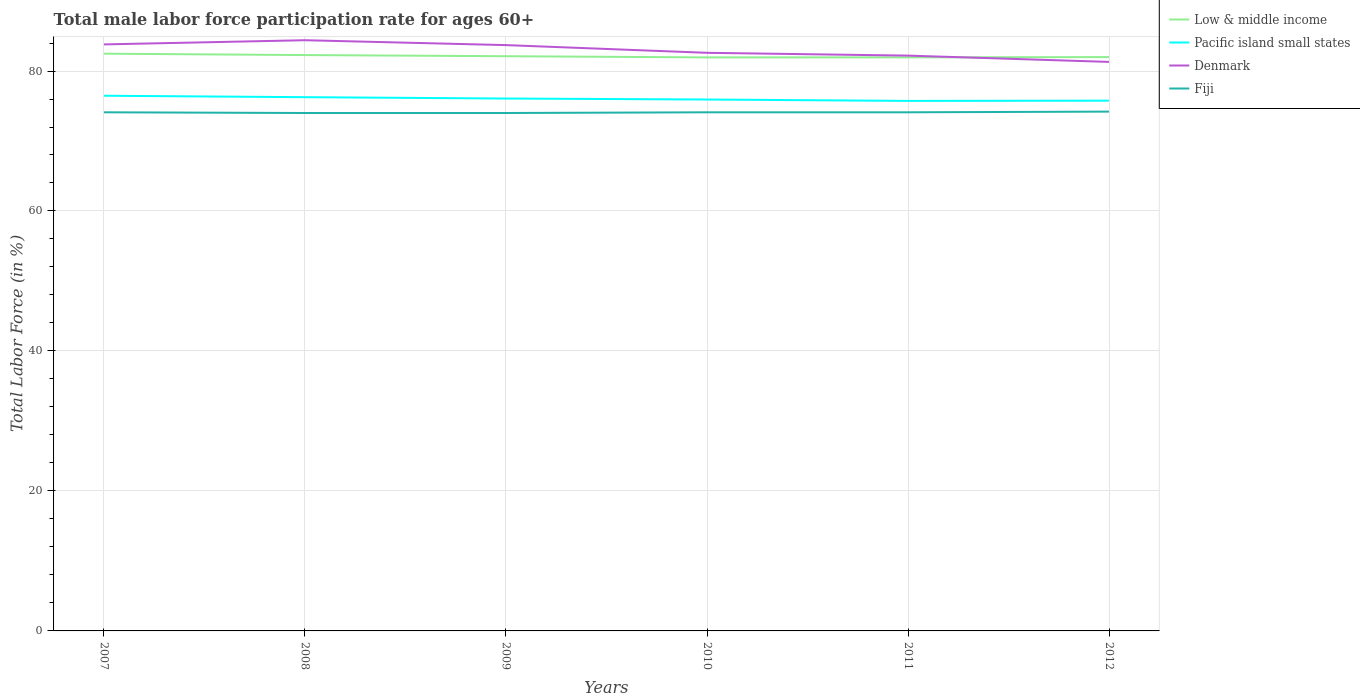Across all years, what is the maximum male labor force participation rate in Pacific island small states?
Ensure brevity in your answer.  75.73. In which year was the male labor force participation rate in Denmark maximum?
Your answer should be very brief. 2012. What is the total male labor force participation rate in Pacific island small states in the graph?
Make the answer very short. 0.14. What is the difference between the highest and the second highest male labor force participation rate in Fiji?
Your answer should be compact. 0.2. How many lines are there?
Your response must be concise. 4. How many years are there in the graph?
Make the answer very short. 6. What is the difference between two consecutive major ticks on the Y-axis?
Your answer should be very brief. 20. Does the graph contain any zero values?
Your answer should be very brief. No. Where does the legend appear in the graph?
Make the answer very short. Top right. How many legend labels are there?
Keep it short and to the point. 4. What is the title of the graph?
Offer a very short reply. Total male labor force participation rate for ages 60+. What is the label or title of the X-axis?
Your response must be concise. Years. What is the Total Labor Force (in %) in Low & middle income in 2007?
Keep it short and to the point. 82.47. What is the Total Labor Force (in %) in Pacific island small states in 2007?
Your answer should be very brief. 76.47. What is the Total Labor Force (in %) of Denmark in 2007?
Give a very brief answer. 83.8. What is the Total Labor Force (in %) of Fiji in 2007?
Ensure brevity in your answer.  74.1. What is the Total Labor Force (in %) in Low & middle income in 2008?
Provide a succinct answer. 82.28. What is the Total Labor Force (in %) of Pacific island small states in 2008?
Your answer should be very brief. 76.26. What is the Total Labor Force (in %) of Denmark in 2008?
Ensure brevity in your answer.  84.4. What is the Total Labor Force (in %) in Low & middle income in 2009?
Keep it short and to the point. 82.11. What is the Total Labor Force (in %) in Pacific island small states in 2009?
Ensure brevity in your answer.  76.07. What is the Total Labor Force (in %) of Denmark in 2009?
Your answer should be compact. 83.7. What is the Total Labor Force (in %) in Low & middle income in 2010?
Provide a short and direct response. 81.94. What is the Total Labor Force (in %) in Pacific island small states in 2010?
Make the answer very short. 75.93. What is the Total Labor Force (in %) in Denmark in 2010?
Ensure brevity in your answer.  82.6. What is the Total Labor Force (in %) of Fiji in 2010?
Make the answer very short. 74.1. What is the Total Labor Force (in %) of Low & middle income in 2011?
Make the answer very short. 81.95. What is the Total Labor Force (in %) of Pacific island small states in 2011?
Ensure brevity in your answer.  75.73. What is the Total Labor Force (in %) in Denmark in 2011?
Offer a terse response. 82.2. What is the Total Labor Force (in %) of Fiji in 2011?
Make the answer very short. 74.1. What is the Total Labor Force (in %) in Low & middle income in 2012?
Your response must be concise. 81.99. What is the Total Labor Force (in %) in Pacific island small states in 2012?
Your answer should be very brief. 75.76. What is the Total Labor Force (in %) of Denmark in 2012?
Your response must be concise. 81.3. What is the Total Labor Force (in %) in Fiji in 2012?
Your response must be concise. 74.2. Across all years, what is the maximum Total Labor Force (in %) of Low & middle income?
Your answer should be very brief. 82.47. Across all years, what is the maximum Total Labor Force (in %) in Pacific island small states?
Provide a succinct answer. 76.47. Across all years, what is the maximum Total Labor Force (in %) in Denmark?
Keep it short and to the point. 84.4. Across all years, what is the maximum Total Labor Force (in %) in Fiji?
Keep it short and to the point. 74.2. Across all years, what is the minimum Total Labor Force (in %) in Low & middle income?
Your response must be concise. 81.94. Across all years, what is the minimum Total Labor Force (in %) in Pacific island small states?
Your answer should be compact. 75.73. Across all years, what is the minimum Total Labor Force (in %) in Denmark?
Keep it short and to the point. 81.3. What is the total Total Labor Force (in %) of Low & middle income in the graph?
Offer a very short reply. 492.75. What is the total Total Labor Force (in %) in Pacific island small states in the graph?
Make the answer very short. 456.22. What is the total Total Labor Force (in %) of Denmark in the graph?
Make the answer very short. 498. What is the total Total Labor Force (in %) of Fiji in the graph?
Your answer should be very brief. 444.5. What is the difference between the Total Labor Force (in %) in Low & middle income in 2007 and that in 2008?
Offer a terse response. 0.2. What is the difference between the Total Labor Force (in %) of Pacific island small states in 2007 and that in 2008?
Keep it short and to the point. 0.21. What is the difference between the Total Labor Force (in %) of Denmark in 2007 and that in 2008?
Provide a succinct answer. -0.6. What is the difference between the Total Labor Force (in %) of Fiji in 2007 and that in 2008?
Your answer should be very brief. 0.1. What is the difference between the Total Labor Force (in %) in Low & middle income in 2007 and that in 2009?
Your response must be concise. 0.36. What is the difference between the Total Labor Force (in %) of Pacific island small states in 2007 and that in 2009?
Make the answer very short. 0.4. What is the difference between the Total Labor Force (in %) in Fiji in 2007 and that in 2009?
Make the answer very short. 0.1. What is the difference between the Total Labor Force (in %) of Low & middle income in 2007 and that in 2010?
Provide a short and direct response. 0.53. What is the difference between the Total Labor Force (in %) in Pacific island small states in 2007 and that in 2010?
Keep it short and to the point. 0.54. What is the difference between the Total Labor Force (in %) of Denmark in 2007 and that in 2010?
Your response must be concise. 1.2. What is the difference between the Total Labor Force (in %) of Low & middle income in 2007 and that in 2011?
Provide a succinct answer. 0.52. What is the difference between the Total Labor Force (in %) in Pacific island small states in 2007 and that in 2011?
Make the answer very short. 0.74. What is the difference between the Total Labor Force (in %) of Low & middle income in 2007 and that in 2012?
Provide a short and direct response. 0.48. What is the difference between the Total Labor Force (in %) in Pacific island small states in 2007 and that in 2012?
Offer a terse response. 0.7. What is the difference between the Total Labor Force (in %) of Denmark in 2007 and that in 2012?
Your answer should be very brief. 2.5. What is the difference between the Total Labor Force (in %) of Low & middle income in 2008 and that in 2009?
Offer a terse response. 0.17. What is the difference between the Total Labor Force (in %) in Pacific island small states in 2008 and that in 2009?
Make the answer very short. 0.19. What is the difference between the Total Labor Force (in %) in Low & middle income in 2008 and that in 2010?
Your answer should be very brief. 0.33. What is the difference between the Total Labor Force (in %) of Pacific island small states in 2008 and that in 2010?
Your answer should be very brief. 0.34. What is the difference between the Total Labor Force (in %) of Denmark in 2008 and that in 2010?
Keep it short and to the point. 1.8. What is the difference between the Total Labor Force (in %) in Fiji in 2008 and that in 2010?
Provide a succinct answer. -0.1. What is the difference between the Total Labor Force (in %) of Low & middle income in 2008 and that in 2011?
Offer a very short reply. 0.33. What is the difference between the Total Labor Force (in %) in Pacific island small states in 2008 and that in 2011?
Make the answer very short. 0.54. What is the difference between the Total Labor Force (in %) of Low & middle income in 2008 and that in 2012?
Provide a short and direct response. 0.29. What is the difference between the Total Labor Force (in %) of Pacific island small states in 2008 and that in 2012?
Ensure brevity in your answer.  0.5. What is the difference between the Total Labor Force (in %) in Denmark in 2008 and that in 2012?
Your response must be concise. 3.1. What is the difference between the Total Labor Force (in %) of Fiji in 2008 and that in 2012?
Keep it short and to the point. -0.2. What is the difference between the Total Labor Force (in %) of Low & middle income in 2009 and that in 2010?
Make the answer very short. 0.17. What is the difference between the Total Labor Force (in %) in Pacific island small states in 2009 and that in 2010?
Provide a short and direct response. 0.14. What is the difference between the Total Labor Force (in %) of Denmark in 2009 and that in 2010?
Ensure brevity in your answer.  1.1. What is the difference between the Total Labor Force (in %) of Fiji in 2009 and that in 2010?
Your answer should be compact. -0.1. What is the difference between the Total Labor Force (in %) in Low & middle income in 2009 and that in 2011?
Your answer should be very brief. 0.16. What is the difference between the Total Labor Force (in %) of Pacific island small states in 2009 and that in 2011?
Provide a succinct answer. 0.34. What is the difference between the Total Labor Force (in %) of Fiji in 2009 and that in 2011?
Give a very brief answer. -0.1. What is the difference between the Total Labor Force (in %) in Low & middle income in 2009 and that in 2012?
Provide a short and direct response. 0.12. What is the difference between the Total Labor Force (in %) of Pacific island small states in 2009 and that in 2012?
Offer a very short reply. 0.3. What is the difference between the Total Labor Force (in %) of Denmark in 2009 and that in 2012?
Your answer should be very brief. 2.4. What is the difference between the Total Labor Force (in %) of Low & middle income in 2010 and that in 2011?
Ensure brevity in your answer.  -0.01. What is the difference between the Total Labor Force (in %) in Pacific island small states in 2010 and that in 2011?
Your answer should be very brief. 0.2. What is the difference between the Total Labor Force (in %) in Fiji in 2010 and that in 2011?
Provide a short and direct response. 0. What is the difference between the Total Labor Force (in %) of Low & middle income in 2010 and that in 2012?
Provide a succinct answer. -0.05. What is the difference between the Total Labor Force (in %) of Pacific island small states in 2010 and that in 2012?
Give a very brief answer. 0.16. What is the difference between the Total Labor Force (in %) in Fiji in 2010 and that in 2012?
Your response must be concise. -0.1. What is the difference between the Total Labor Force (in %) of Low & middle income in 2011 and that in 2012?
Provide a succinct answer. -0.04. What is the difference between the Total Labor Force (in %) in Pacific island small states in 2011 and that in 2012?
Provide a short and direct response. -0.04. What is the difference between the Total Labor Force (in %) of Low & middle income in 2007 and the Total Labor Force (in %) of Pacific island small states in 2008?
Make the answer very short. 6.21. What is the difference between the Total Labor Force (in %) of Low & middle income in 2007 and the Total Labor Force (in %) of Denmark in 2008?
Give a very brief answer. -1.93. What is the difference between the Total Labor Force (in %) in Low & middle income in 2007 and the Total Labor Force (in %) in Fiji in 2008?
Provide a short and direct response. 8.47. What is the difference between the Total Labor Force (in %) of Pacific island small states in 2007 and the Total Labor Force (in %) of Denmark in 2008?
Your answer should be compact. -7.93. What is the difference between the Total Labor Force (in %) in Pacific island small states in 2007 and the Total Labor Force (in %) in Fiji in 2008?
Provide a short and direct response. 2.47. What is the difference between the Total Labor Force (in %) of Denmark in 2007 and the Total Labor Force (in %) of Fiji in 2008?
Give a very brief answer. 9.8. What is the difference between the Total Labor Force (in %) in Low & middle income in 2007 and the Total Labor Force (in %) in Pacific island small states in 2009?
Provide a succinct answer. 6.41. What is the difference between the Total Labor Force (in %) in Low & middle income in 2007 and the Total Labor Force (in %) in Denmark in 2009?
Give a very brief answer. -1.23. What is the difference between the Total Labor Force (in %) of Low & middle income in 2007 and the Total Labor Force (in %) of Fiji in 2009?
Make the answer very short. 8.47. What is the difference between the Total Labor Force (in %) of Pacific island small states in 2007 and the Total Labor Force (in %) of Denmark in 2009?
Keep it short and to the point. -7.23. What is the difference between the Total Labor Force (in %) in Pacific island small states in 2007 and the Total Labor Force (in %) in Fiji in 2009?
Offer a very short reply. 2.47. What is the difference between the Total Labor Force (in %) in Denmark in 2007 and the Total Labor Force (in %) in Fiji in 2009?
Give a very brief answer. 9.8. What is the difference between the Total Labor Force (in %) of Low & middle income in 2007 and the Total Labor Force (in %) of Pacific island small states in 2010?
Provide a succinct answer. 6.55. What is the difference between the Total Labor Force (in %) of Low & middle income in 2007 and the Total Labor Force (in %) of Denmark in 2010?
Keep it short and to the point. -0.13. What is the difference between the Total Labor Force (in %) in Low & middle income in 2007 and the Total Labor Force (in %) in Fiji in 2010?
Offer a very short reply. 8.37. What is the difference between the Total Labor Force (in %) in Pacific island small states in 2007 and the Total Labor Force (in %) in Denmark in 2010?
Offer a terse response. -6.13. What is the difference between the Total Labor Force (in %) in Pacific island small states in 2007 and the Total Labor Force (in %) in Fiji in 2010?
Your response must be concise. 2.37. What is the difference between the Total Labor Force (in %) in Denmark in 2007 and the Total Labor Force (in %) in Fiji in 2010?
Give a very brief answer. 9.7. What is the difference between the Total Labor Force (in %) in Low & middle income in 2007 and the Total Labor Force (in %) in Pacific island small states in 2011?
Offer a very short reply. 6.75. What is the difference between the Total Labor Force (in %) of Low & middle income in 2007 and the Total Labor Force (in %) of Denmark in 2011?
Offer a very short reply. 0.27. What is the difference between the Total Labor Force (in %) of Low & middle income in 2007 and the Total Labor Force (in %) of Fiji in 2011?
Offer a terse response. 8.37. What is the difference between the Total Labor Force (in %) of Pacific island small states in 2007 and the Total Labor Force (in %) of Denmark in 2011?
Your answer should be compact. -5.73. What is the difference between the Total Labor Force (in %) in Pacific island small states in 2007 and the Total Labor Force (in %) in Fiji in 2011?
Give a very brief answer. 2.37. What is the difference between the Total Labor Force (in %) of Denmark in 2007 and the Total Labor Force (in %) of Fiji in 2011?
Provide a succinct answer. 9.7. What is the difference between the Total Labor Force (in %) of Low & middle income in 2007 and the Total Labor Force (in %) of Pacific island small states in 2012?
Ensure brevity in your answer.  6.71. What is the difference between the Total Labor Force (in %) in Low & middle income in 2007 and the Total Labor Force (in %) in Denmark in 2012?
Your answer should be compact. 1.17. What is the difference between the Total Labor Force (in %) in Low & middle income in 2007 and the Total Labor Force (in %) in Fiji in 2012?
Ensure brevity in your answer.  8.27. What is the difference between the Total Labor Force (in %) in Pacific island small states in 2007 and the Total Labor Force (in %) in Denmark in 2012?
Offer a terse response. -4.83. What is the difference between the Total Labor Force (in %) of Pacific island small states in 2007 and the Total Labor Force (in %) of Fiji in 2012?
Offer a very short reply. 2.27. What is the difference between the Total Labor Force (in %) of Low & middle income in 2008 and the Total Labor Force (in %) of Pacific island small states in 2009?
Your answer should be very brief. 6.21. What is the difference between the Total Labor Force (in %) in Low & middle income in 2008 and the Total Labor Force (in %) in Denmark in 2009?
Offer a terse response. -1.42. What is the difference between the Total Labor Force (in %) of Low & middle income in 2008 and the Total Labor Force (in %) of Fiji in 2009?
Offer a terse response. 8.28. What is the difference between the Total Labor Force (in %) of Pacific island small states in 2008 and the Total Labor Force (in %) of Denmark in 2009?
Provide a short and direct response. -7.44. What is the difference between the Total Labor Force (in %) in Pacific island small states in 2008 and the Total Labor Force (in %) in Fiji in 2009?
Your answer should be very brief. 2.26. What is the difference between the Total Labor Force (in %) in Denmark in 2008 and the Total Labor Force (in %) in Fiji in 2009?
Make the answer very short. 10.4. What is the difference between the Total Labor Force (in %) in Low & middle income in 2008 and the Total Labor Force (in %) in Pacific island small states in 2010?
Give a very brief answer. 6.35. What is the difference between the Total Labor Force (in %) in Low & middle income in 2008 and the Total Labor Force (in %) in Denmark in 2010?
Your response must be concise. -0.32. What is the difference between the Total Labor Force (in %) of Low & middle income in 2008 and the Total Labor Force (in %) of Fiji in 2010?
Offer a terse response. 8.18. What is the difference between the Total Labor Force (in %) in Pacific island small states in 2008 and the Total Labor Force (in %) in Denmark in 2010?
Provide a short and direct response. -6.34. What is the difference between the Total Labor Force (in %) in Pacific island small states in 2008 and the Total Labor Force (in %) in Fiji in 2010?
Make the answer very short. 2.16. What is the difference between the Total Labor Force (in %) of Low & middle income in 2008 and the Total Labor Force (in %) of Pacific island small states in 2011?
Offer a terse response. 6.55. What is the difference between the Total Labor Force (in %) of Low & middle income in 2008 and the Total Labor Force (in %) of Denmark in 2011?
Provide a short and direct response. 0.08. What is the difference between the Total Labor Force (in %) of Low & middle income in 2008 and the Total Labor Force (in %) of Fiji in 2011?
Offer a terse response. 8.18. What is the difference between the Total Labor Force (in %) in Pacific island small states in 2008 and the Total Labor Force (in %) in Denmark in 2011?
Offer a very short reply. -5.94. What is the difference between the Total Labor Force (in %) of Pacific island small states in 2008 and the Total Labor Force (in %) of Fiji in 2011?
Give a very brief answer. 2.16. What is the difference between the Total Labor Force (in %) in Low & middle income in 2008 and the Total Labor Force (in %) in Pacific island small states in 2012?
Give a very brief answer. 6.52. What is the difference between the Total Labor Force (in %) of Low & middle income in 2008 and the Total Labor Force (in %) of Denmark in 2012?
Give a very brief answer. 0.98. What is the difference between the Total Labor Force (in %) of Low & middle income in 2008 and the Total Labor Force (in %) of Fiji in 2012?
Your response must be concise. 8.08. What is the difference between the Total Labor Force (in %) of Pacific island small states in 2008 and the Total Labor Force (in %) of Denmark in 2012?
Offer a very short reply. -5.04. What is the difference between the Total Labor Force (in %) in Pacific island small states in 2008 and the Total Labor Force (in %) in Fiji in 2012?
Your answer should be compact. 2.06. What is the difference between the Total Labor Force (in %) in Denmark in 2008 and the Total Labor Force (in %) in Fiji in 2012?
Your answer should be compact. 10.2. What is the difference between the Total Labor Force (in %) in Low & middle income in 2009 and the Total Labor Force (in %) in Pacific island small states in 2010?
Your answer should be compact. 6.19. What is the difference between the Total Labor Force (in %) of Low & middle income in 2009 and the Total Labor Force (in %) of Denmark in 2010?
Keep it short and to the point. -0.49. What is the difference between the Total Labor Force (in %) of Low & middle income in 2009 and the Total Labor Force (in %) of Fiji in 2010?
Keep it short and to the point. 8.01. What is the difference between the Total Labor Force (in %) of Pacific island small states in 2009 and the Total Labor Force (in %) of Denmark in 2010?
Provide a succinct answer. -6.53. What is the difference between the Total Labor Force (in %) in Pacific island small states in 2009 and the Total Labor Force (in %) in Fiji in 2010?
Make the answer very short. 1.97. What is the difference between the Total Labor Force (in %) in Denmark in 2009 and the Total Labor Force (in %) in Fiji in 2010?
Offer a very short reply. 9.6. What is the difference between the Total Labor Force (in %) of Low & middle income in 2009 and the Total Labor Force (in %) of Pacific island small states in 2011?
Keep it short and to the point. 6.39. What is the difference between the Total Labor Force (in %) in Low & middle income in 2009 and the Total Labor Force (in %) in Denmark in 2011?
Provide a short and direct response. -0.09. What is the difference between the Total Labor Force (in %) of Low & middle income in 2009 and the Total Labor Force (in %) of Fiji in 2011?
Offer a very short reply. 8.01. What is the difference between the Total Labor Force (in %) of Pacific island small states in 2009 and the Total Labor Force (in %) of Denmark in 2011?
Your answer should be very brief. -6.13. What is the difference between the Total Labor Force (in %) in Pacific island small states in 2009 and the Total Labor Force (in %) in Fiji in 2011?
Provide a short and direct response. 1.97. What is the difference between the Total Labor Force (in %) in Low & middle income in 2009 and the Total Labor Force (in %) in Pacific island small states in 2012?
Offer a terse response. 6.35. What is the difference between the Total Labor Force (in %) in Low & middle income in 2009 and the Total Labor Force (in %) in Denmark in 2012?
Your answer should be very brief. 0.81. What is the difference between the Total Labor Force (in %) of Low & middle income in 2009 and the Total Labor Force (in %) of Fiji in 2012?
Your response must be concise. 7.91. What is the difference between the Total Labor Force (in %) in Pacific island small states in 2009 and the Total Labor Force (in %) in Denmark in 2012?
Provide a short and direct response. -5.23. What is the difference between the Total Labor Force (in %) in Pacific island small states in 2009 and the Total Labor Force (in %) in Fiji in 2012?
Give a very brief answer. 1.87. What is the difference between the Total Labor Force (in %) in Denmark in 2009 and the Total Labor Force (in %) in Fiji in 2012?
Give a very brief answer. 9.5. What is the difference between the Total Labor Force (in %) of Low & middle income in 2010 and the Total Labor Force (in %) of Pacific island small states in 2011?
Keep it short and to the point. 6.22. What is the difference between the Total Labor Force (in %) of Low & middle income in 2010 and the Total Labor Force (in %) of Denmark in 2011?
Provide a short and direct response. -0.26. What is the difference between the Total Labor Force (in %) in Low & middle income in 2010 and the Total Labor Force (in %) in Fiji in 2011?
Ensure brevity in your answer.  7.84. What is the difference between the Total Labor Force (in %) in Pacific island small states in 2010 and the Total Labor Force (in %) in Denmark in 2011?
Keep it short and to the point. -6.27. What is the difference between the Total Labor Force (in %) in Pacific island small states in 2010 and the Total Labor Force (in %) in Fiji in 2011?
Ensure brevity in your answer.  1.83. What is the difference between the Total Labor Force (in %) of Low & middle income in 2010 and the Total Labor Force (in %) of Pacific island small states in 2012?
Make the answer very short. 6.18. What is the difference between the Total Labor Force (in %) of Low & middle income in 2010 and the Total Labor Force (in %) of Denmark in 2012?
Provide a succinct answer. 0.64. What is the difference between the Total Labor Force (in %) of Low & middle income in 2010 and the Total Labor Force (in %) of Fiji in 2012?
Your response must be concise. 7.74. What is the difference between the Total Labor Force (in %) of Pacific island small states in 2010 and the Total Labor Force (in %) of Denmark in 2012?
Provide a succinct answer. -5.37. What is the difference between the Total Labor Force (in %) in Pacific island small states in 2010 and the Total Labor Force (in %) in Fiji in 2012?
Make the answer very short. 1.73. What is the difference between the Total Labor Force (in %) in Denmark in 2010 and the Total Labor Force (in %) in Fiji in 2012?
Your answer should be compact. 8.4. What is the difference between the Total Labor Force (in %) in Low & middle income in 2011 and the Total Labor Force (in %) in Pacific island small states in 2012?
Ensure brevity in your answer.  6.19. What is the difference between the Total Labor Force (in %) of Low & middle income in 2011 and the Total Labor Force (in %) of Denmark in 2012?
Give a very brief answer. 0.65. What is the difference between the Total Labor Force (in %) of Low & middle income in 2011 and the Total Labor Force (in %) of Fiji in 2012?
Your answer should be very brief. 7.75. What is the difference between the Total Labor Force (in %) in Pacific island small states in 2011 and the Total Labor Force (in %) in Denmark in 2012?
Your answer should be compact. -5.57. What is the difference between the Total Labor Force (in %) in Pacific island small states in 2011 and the Total Labor Force (in %) in Fiji in 2012?
Ensure brevity in your answer.  1.53. What is the difference between the Total Labor Force (in %) in Denmark in 2011 and the Total Labor Force (in %) in Fiji in 2012?
Ensure brevity in your answer.  8. What is the average Total Labor Force (in %) of Low & middle income per year?
Offer a terse response. 82.13. What is the average Total Labor Force (in %) in Pacific island small states per year?
Your answer should be very brief. 76.04. What is the average Total Labor Force (in %) in Fiji per year?
Keep it short and to the point. 74.08. In the year 2007, what is the difference between the Total Labor Force (in %) in Low & middle income and Total Labor Force (in %) in Pacific island small states?
Give a very brief answer. 6.01. In the year 2007, what is the difference between the Total Labor Force (in %) in Low & middle income and Total Labor Force (in %) in Denmark?
Provide a short and direct response. -1.33. In the year 2007, what is the difference between the Total Labor Force (in %) of Low & middle income and Total Labor Force (in %) of Fiji?
Keep it short and to the point. 8.37. In the year 2007, what is the difference between the Total Labor Force (in %) in Pacific island small states and Total Labor Force (in %) in Denmark?
Give a very brief answer. -7.33. In the year 2007, what is the difference between the Total Labor Force (in %) in Pacific island small states and Total Labor Force (in %) in Fiji?
Keep it short and to the point. 2.37. In the year 2008, what is the difference between the Total Labor Force (in %) of Low & middle income and Total Labor Force (in %) of Pacific island small states?
Provide a short and direct response. 6.02. In the year 2008, what is the difference between the Total Labor Force (in %) of Low & middle income and Total Labor Force (in %) of Denmark?
Your response must be concise. -2.12. In the year 2008, what is the difference between the Total Labor Force (in %) in Low & middle income and Total Labor Force (in %) in Fiji?
Keep it short and to the point. 8.28. In the year 2008, what is the difference between the Total Labor Force (in %) of Pacific island small states and Total Labor Force (in %) of Denmark?
Your response must be concise. -8.14. In the year 2008, what is the difference between the Total Labor Force (in %) of Pacific island small states and Total Labor Force (in %) of Fiji?
Your answer should be very brief. 2.26. In the year 2009, what is the difference between the Total Labor Force (in %) of Low & middle income and Total Labor Force (in %) of Pacific island small states?
Ensure brevity in your answer.  6.05. In the year 2009, what is the difference between the Total Labor Force (in %) of Low & middle income and Total Labor Force (in %) of Denmark?
Your response must be concise. -1.59. In the year 2009, what is the difference between the Total Labor Force (in %) of Low & middle income and Total Labor Force (in %) of Fiji?
Keep it short and to the point. 8.11. In the year 2009, what is the difference between the Total Labor Force (in %) in Pacific island small states and Total Labor Force (in %) in Denmark?
Keep it short and to the point. -7.63. In the year 2009, what is the difference between the Total Labor Force (in %) in Pacific island small states and Total Labor Force (in %) in Fiji?
Ensure brevity in your answer.  2.07. In the year 2009, what is the difference between the Total Labor Force (in %) of Denmark and Total Labor Force (in %) of Fiji?
Provide a short and direct response. 9.7. In the year 2010, what is the difference between the Total Labor Force (in %) in Low & middle income and Total Labor Force (in %) in Pacific island small states?
Your response must be concise. 6.02. In the year 2010, what is the difference between the Total Labor Force (in %) of Low & middle income and Total Labor Force (in %) of Denmark?
Give a very brief answer. -0.66. In the year 2010, what is the difference between the Total Labor Force (in %) of Low & middle income and Total Labor Force (in %) of Fiji?
Your answer should be very brief. 7.84. In the year 2010, what is the difference between the Total Labor Force (in %) in Pacific island small states and Total Labor Force (in %) in Denmark?
Provide a succinct answer. -6.67. In the year 2010, what is the difference between the Total Labor Force (in %) of Pacific island small states and Total Labor Force (in %) of Fiji?
Offer a very short reply. 1.83. In the year 2010, what is the difference between the Total Labor Force (in %) of Denmark and Total Labor Force (in %) of Fiji?
Ensure brevity in your answer.  8.5. In the year 2011, what is the difference between the Total Labor Force (in %) of Low & middle income and Total Labor Force (in %) of Pacific island small states?
Keep it short and to the point. 6.22. In the year 2011, what is the difference between the Total Labor Force (in %) in Low & middle income and Total Labor Force (in %) in Fiji?
Give a very brief answer. 7.85. In the year 2011, what is the difference between the Total Labor Force (in %) of Pacific island small states and Total Labor Force (in %) of Denmark?
Provide a succinct answer. -6.47. In the year 2011, what is the difference between the Total Labor Force (in %) in Pacific island small states and Total Labor Force (in %) in Fiji?
Ensure brevity in your answer.  1.63. In the year 2012, what is the difference between the Total Labor Force (in %) of Low & middle income and Total Labor Force (in %) of Pacific island small states?
Give a very brief answer. 6.23. In the year 2012, what is the difference between the Total Labor Force (in %) of Low & middle income and Total Labor Force (in %) of Denmark?
Your answer should be very brief. 0.69. In the year 2012, what is the difference between the Total Labor Force (in %) in Low & middle income and Total Labor Force (in %) in Fiji?
Provide a short and direct response. 7.79. In the year 2012, what is the difference between the Total Labor Force (in %) in Pacific island small states and Total Labor Force (in %) in Denmark?
Your answer should be very brief. -5.54. In the year 2012, what is the difference between the Total Labor Force (in %) in Pacific island small states and Total Labor Force (in %) in Fiji?
Offer a terse response. 1.56. In the year 2012, what is the difference between the Total Labor Force (in %) in Denmark and Total Labor Force (in %) in Fiji?
Provide a succinct answer. 7.1. What is the ratio of the Total Labor Force (in %) in Pacific island small states in 2007 to that in 2008?
Give a very brief answer. 1. What is the ratio of the Total Labor Force (in %) of Pacific island small states in 2007 to that in 2009?
Your response must be concise. 1.01. What is the ratio of the Total Labor Force (in %) in Denmark in 2007 to that in 2009?
Your answer should be compact. 1. What is the ratio of the Total Labor Force (in %) of Low & middle income in 2007 to that in 2010?
Provide a short and direct response. 1.01. What is the ratio of the Total Labor Force (in %) in Pacific island small states in 2007 to that in 2010?
Make the answer very short. 1.01. What is the ratio of the Total Labor Force (in %) in Denmark in 2007 to that in 2010?
Give a very brief answer. 1.01. What is the ratio of the Total Labor Force (in %) of Fiji in 2007 to that in 2010?
Offer a terse response. 1. What is the ratio of the Total Labor Force (in %) in Low & middle income in 2007 to that in 2011?
Provide a short and direct response. 1.01. What is the ratio of the Total Labor Force (in %) of Pacific island small states in 2007 to that in 2011?
Offer a very short reply. 1.01. What is the ratio of the Total Labor Force (in %) in Denmark in 2007 to that in 2011?
Provide a succinct answer. 1.02. What is the ratio of the Total Labor Force (in %) of Fiji in 2007 to that in 2011?
Give a very brief answer. 1. What is the ratio of the Total Labor Force (in %) in Low & middle income in 2007 to that in 2012?
Offer a terse response. 1.01. What is the ratio of the Total Labor Force (in %) in Pacific island small states in 2007 to that in 2012?
Your response must be concise. 1.01. What is the ratio of the Total Labor Force (in %) in Denmark in 2007 to that in 2012?
Make the answer very short. 1.03. What is the ratio of the Total Labor Force (in %) of Fiji in 2007 to that in 2012?
Your answer should be very brief. 1. What is the ratio of the Total Labor Force (in %) of Denmark in 2008 to that in 2009?
Your response must be concise. 1.01. What is the ratio of the Total Labor Force (in %) of Low & middle income in 2008 to that in 2010?
Provide a succinct answer. 1. What is the ratio of the Total Labor Force (in %) in Pacific island small states in 2008 to that in 2010?
Offer a very short reply. 1. What is the ratio of the Total Labor Force (in %) of Denmark in 2008 to that in 2010?
Offer a very short reply. 1.02. What is the ratio of the Total Labor Force (in %) in Fiji in 2008 to that in 2010?
Ensure brevity in your answer.  1. What is the ratio of the Total Labor Force (in %) of Pacific island small states in 2008 to that in 2011?
Ensure brevity in your answer.  1.01. What is the ratio of the Total Labor Force (in %) of Denmark in 2008 to that in 2011?
Your answer should be very brief. 1.03. What is the ratio of the Total Labor Force (in %) of Fiji in 2008 to that in 2011?
Make the answer very short. 1. What is the ratio of the Total Labor Force (in %) in Pacific island small states in 2008 to that in 2012?
Your response must be concise. 1.01. What is the ratio of the Total Labor Force (in %) of Denmark in 2008 to that in 2012?
Your response must be concise. 1.04. What is the ratio of the Total Labor Force (in %) of Fiji in 2008 to that in 2012?
Your answer should be very brief. 1. What is the ratio of the Total Labor Force (in %) in Denmark in 2009 to that in 2010?
Offer a very short reply. 1.01. What is the ratio of the Total Labor Force (in %) of Fiji in 2009 to that in 2010?
Offer a terse response. 1. What is the ratio of the Total Labor Force (in %) in Low & middle income in 2009 to that in 2011?
Provide a succinct answer. 1. What is the ratio of the Total Labor Force (in %) of Denmark in 2009 to that in 2011?
Offer a very short reply. 1.02. What is the ratio of the Total Labor Force (in %) in Pacific island small states in 2009 to that in 2012?
Provide a short and direct response. 1. What is the ratio of the Total Labor Force (in %) of Denmark in 2009 to that in 2012?
Ensure brevity in your answer.  1.03. What is the ratio of the Total Labor Force (in %) of Fiji in 2009 to that in 2012?
Give a very brief answer. 1. What is the ratio of the Total Labor Force (in %) of Low & middle income in 2010 to that in 2011?
Keep it short and to the point. 1. What is the ratio of the Total Labor Force (in %) of Low & middle income in 2010 to that in 2012?
Provide a succinct answer. 1. What is the ratio of the Total Labor Force (in %) of Pacific island small states in 2010 to that in 2012?
Keep it short and to the point. 1. What is the ratio of the Total Labor Force (in %) in Denmark in 2010 to that in 2012?
Offer a terse response. 1.02. What is the ratio of the Total Labor Force (in %) in Fiji in 2010 to that in 2012?
Provide a short and direct response. 1. What is the ratio of the Total Labor Force (in %) in Low & middle income in 2011 to that in 2012?
Provide a short and direct response. 1. What is the ratio of the Total Labor Force (in %) of Denmark in 2011 to that in 2012?
Give a very brief answer. 1.01. What is the ratio of the Total Labor Force (in %) of Fiji in 2011 to that in 2012?
Provide a short and direct response. 1. What is the difference between the highest and the second highest Total Labor Force (in %) of Low & middle income?
Make the answer very short. 0.2. What is the difference between the highest and the second highest Total Labor Force (in %) in Pacific island small states?
Provide a succinct answer. 0.21. What is the difference between the highest and the lowest Total Labor Force (in %) in Low & middle income?
Offer a terse response. 0.53. What is the difference between the highest and the lowest Total Labor Force (in %) of Pacific island small states?
Give a very brief answer. 0.74. What is the difference between the highest and the lowest Total Labor Force (in %) of Fiji?
Provide a short and direct response. 0.2. 